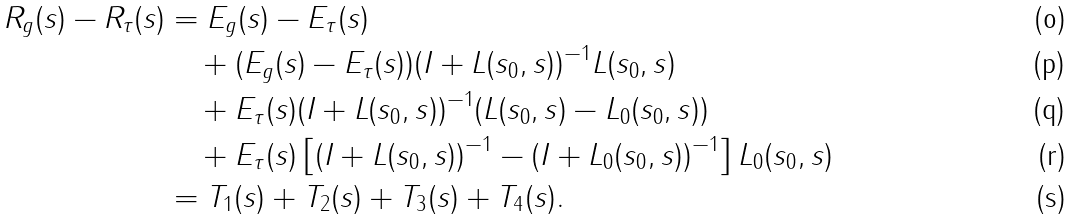<formula> <loc_0><loc_0><loc_500><loc_500>R _ { g } ( s ) - R _ { \tau } ( s ) & = E _ { g } ( s ) - E _ { \tau } ( s ) \\ & \quad + ( E _ { g } ( s ) - E _ { \tau } ( s ) ) ( I + L ( s _ { 0 } , s ) ) ^ { - 1 } L ( s _ { 0 } , s ) \\ & \quad + E _ { \tau } ( s ) ( I + L ( s _ { 0 } , s ) ) ^ { - 1 } ( L ( s _ { 0 } , s ) - L _ { 0 } ( s _ { 0 } , s ) ) \\ & \quad + E _ { \tau } ( s ) \left [ ( I + L ( s _ { 0 } , s ) ) ^ { - 1 } - ( I + L _ { 0 } ( s _ { 0 } , s ) ) ^ { - 1 } \right ] L _ { 0 } ( s _ { 0 } , s ) \\ & = T _ { 1 } ( s ) + T _ { 2 } ( s ) + T _ { 3 } ( s ) + T _ { 4 } ( s ) .</formula> 